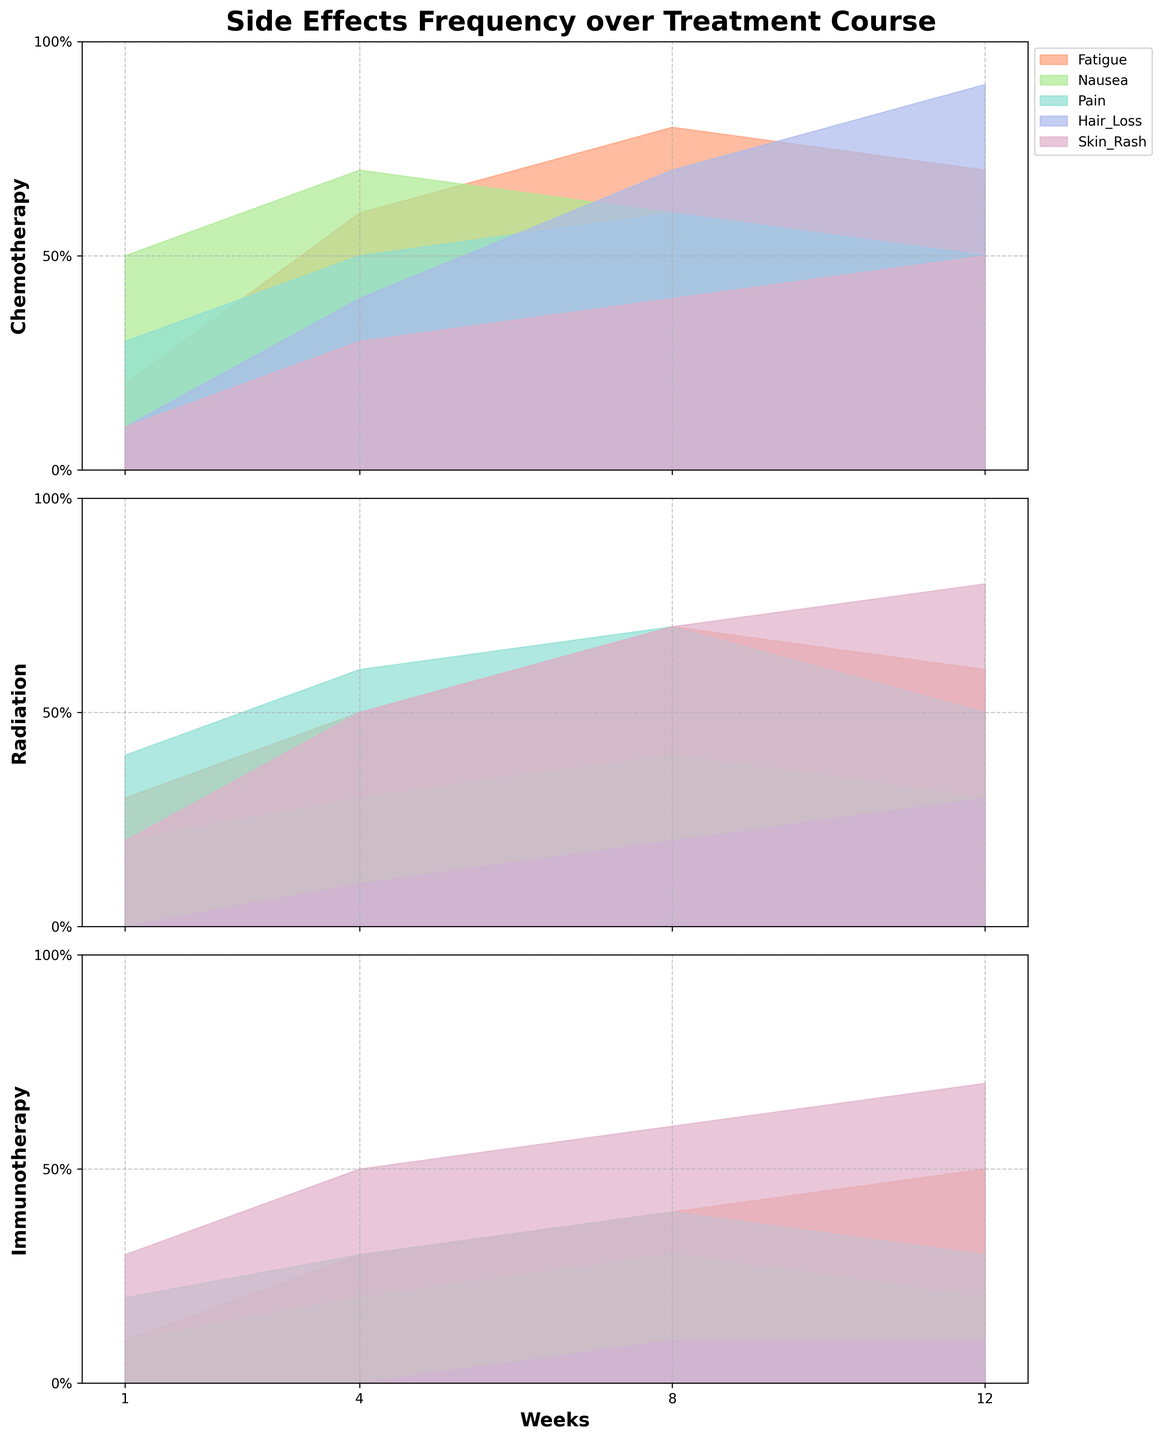How many weeks of data are there for each treatment? The x-axis is labeled "Weeks," and data points are plotted at 1, 4, 8, and 12 weeks for each of the treatments. Therefore, each treatment has data for 4 weeks.
Answer: 4 What's the trend of fatigue over time for chemotherapy? The plot for chemotherapy shows that the fatigue line starts at 0.2, increases to 0.6 at week 4, peaks at 0.8 at week 8, and then slightly decreases to 0.7 at week 12.
Answer: Increases, peaks, then slightly decreases Which treatment has the highest frequency of skin rash at week 12? By examining the values at week 12 across different treatments, the highest frequency for skin rash is 0.8 in Radiation treatment.
Answer: Radiation Between chemotherapy and immunotherapy, which treatment shows a higher increase in fatigue from week 1 to week 12? In chemotherapy, fatigue increases from 0.2 to 0.7 (an increase of 0.5). In immunotherapy, fatigue increases from 0.1 to 0.5 (an increase of 0.4). Therefore, chemotherapy has a higher increase.
Answer: Chemotherapy During which week does radiation treatment have the highest frequency of pain? The pain frequency line for radiation is highest at week 8, with a frequency value of 0.7.
Answer: Week 8 Is hair loss more prevalent in chemotherapy or radiation at week 8? At week 8, hair loss frequency for chemotherapy is 0.7, while for radiation, it is 0.2. Hair loss is more prevalent in chemotherapy.
Answer: Chemotherapy Describe the trend of nausea over time in immunotherapy treatment. Nausea frequency for immunotherapy slightly increases from 0.1 at week 1 to 0.2 at week 4, then to 0.3 at week 8, and back to 0.2 at week 12, indicating a slight up-and-down trend but generally remaining low.
Answer: Slight increase, then slight decrease Which side effect shows the highest initial frequency across all treatments at week 1? By looking at week 1 for all treatments, nausea in chemotherapy has the highest initial frequency at 0.5.
Answer: Nausea in chemotherapy What side effect in radiation treatment shows the most consistent level over 12 weeks? Skin rash shows a consistent increasing trend from 0.2 in week 1 up to 0.8 at week 12 with relatively steady increments. Other side effects show more fluctuations.
Answer: Skin rash Compare the trends of hair loss in chemotherapy and radiation from week 1 to week 12. In chemotherapy, hair loss steadily increases from 0.1 (week 1) to 0.9 (week 12). In radiation, it starts at 0.0, then slowly rises to 0.3 at week 12. Hair loss is more pronounced and increases more steeply in chemotherapy.
Answer: More pronounced in chemotherapy 